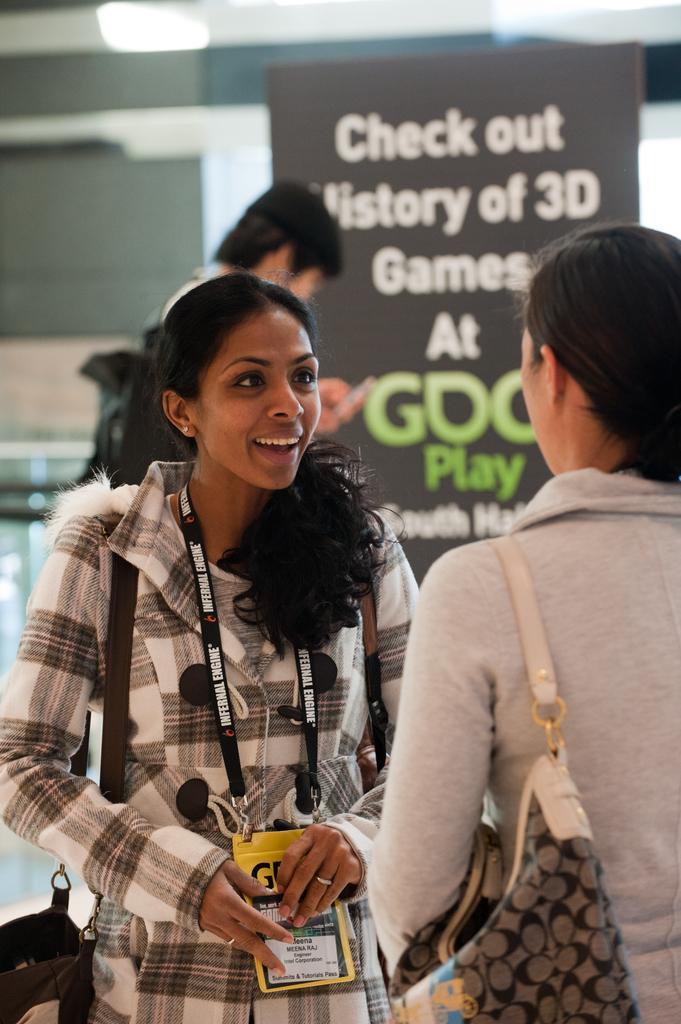Describe this image in one or two sentences. In this image we can see three persons, one of them is holding a cell phone, two ladies are carrying bags, there is a board with text on it, also we can see the wall and a light. 